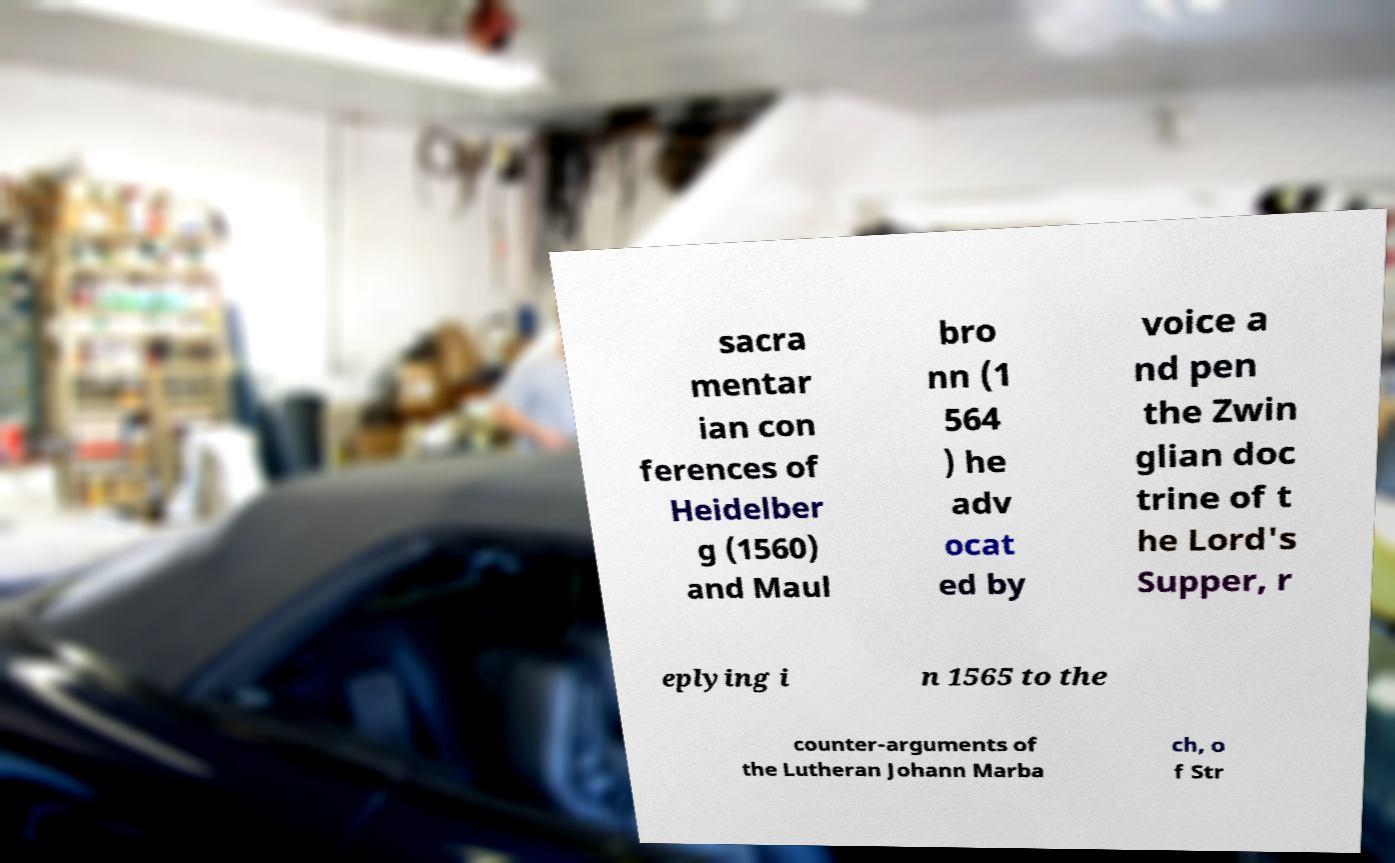Please identify and transcribe the text found in this image. sacra mentar ian con ferences of Heidelber g (1560) and Maul bro nn (1 564 ) he adv ocat ed by voice a nd pen the Zwin glian doc trine of t he Lord's Supper, r eplying i n 1565 to the counter-arguments of the Lutheran Johann Marba ch, o f Str 